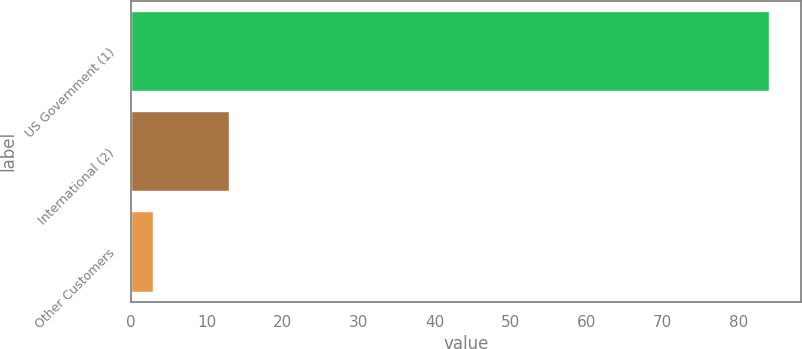<chart> <loc_0><loc_0><loc_500><loc_500><bar_chart><fcel>US Government (1)<fcel>International (2)<fcel>Other Customers<nl><fcel>84<fcel>13<fcel>3<nl></chart> 